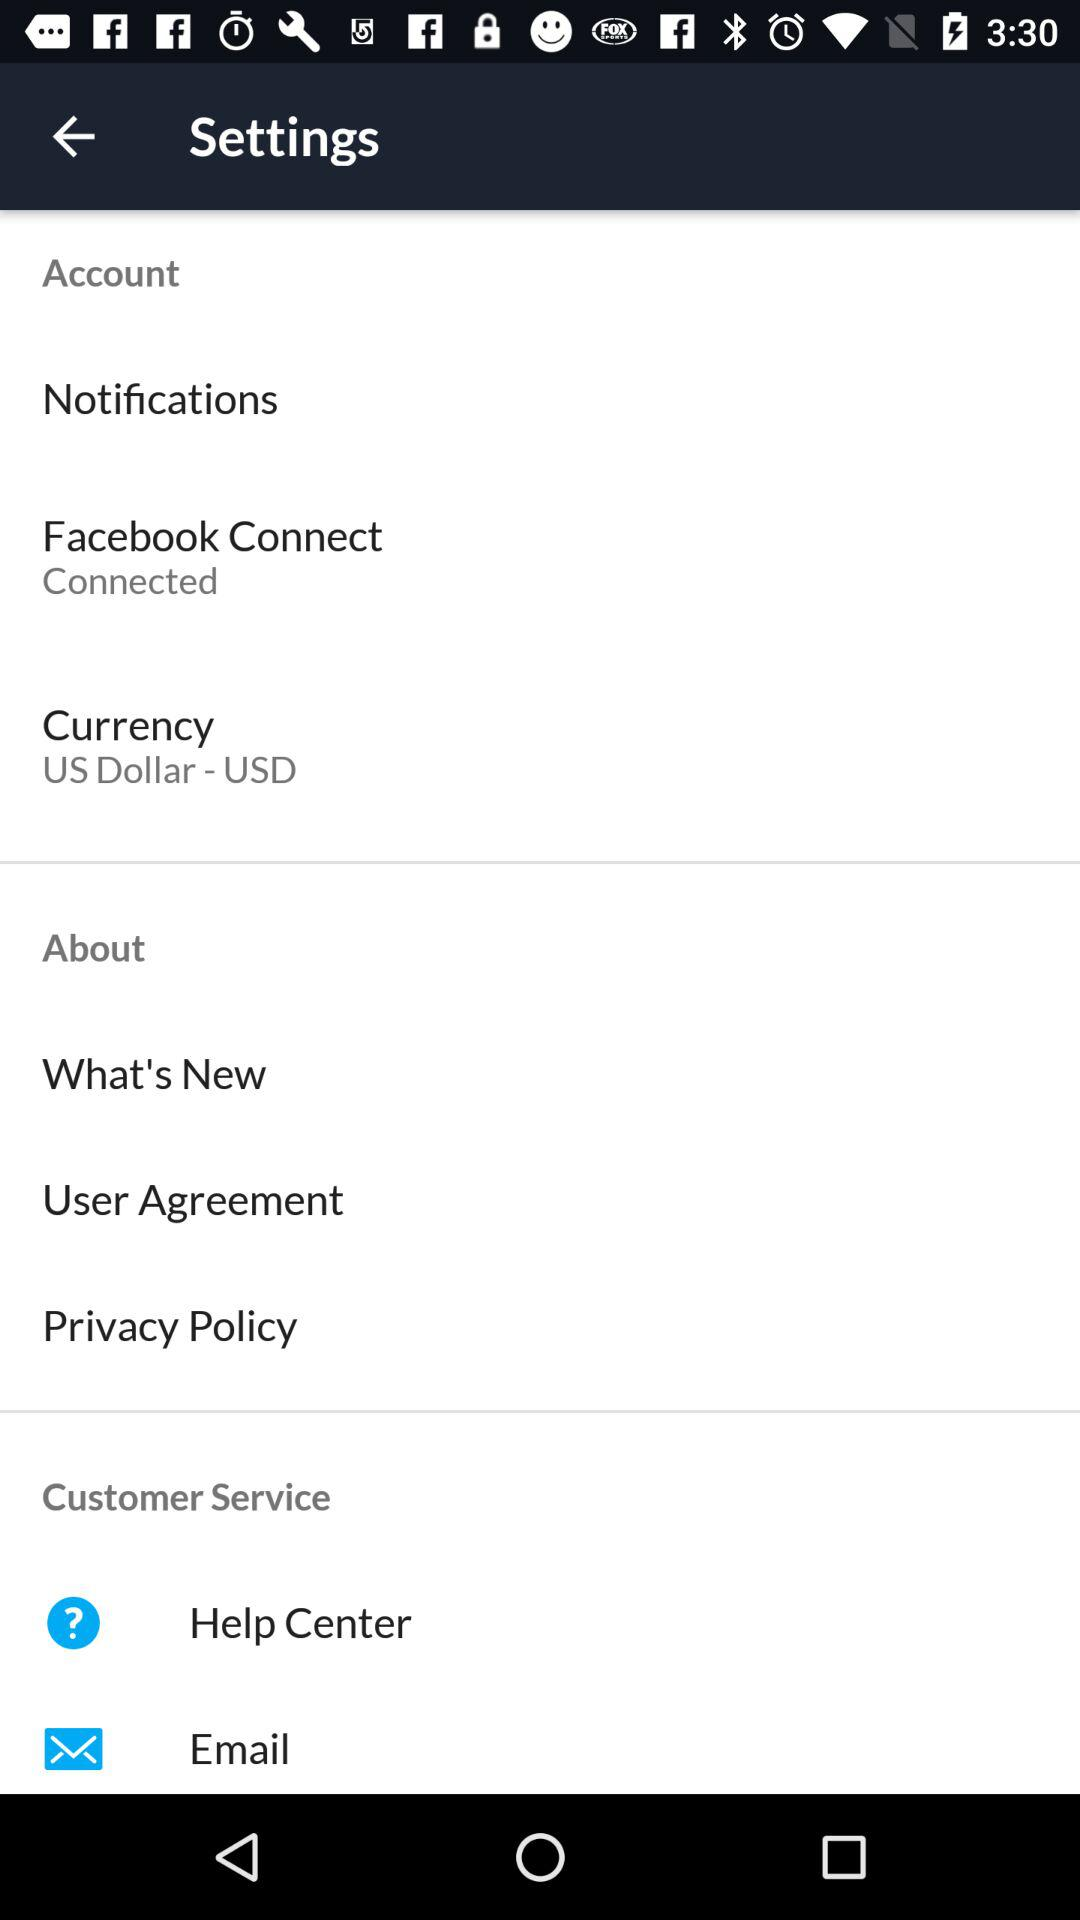What is the currency? The currency is the US Dollar. 